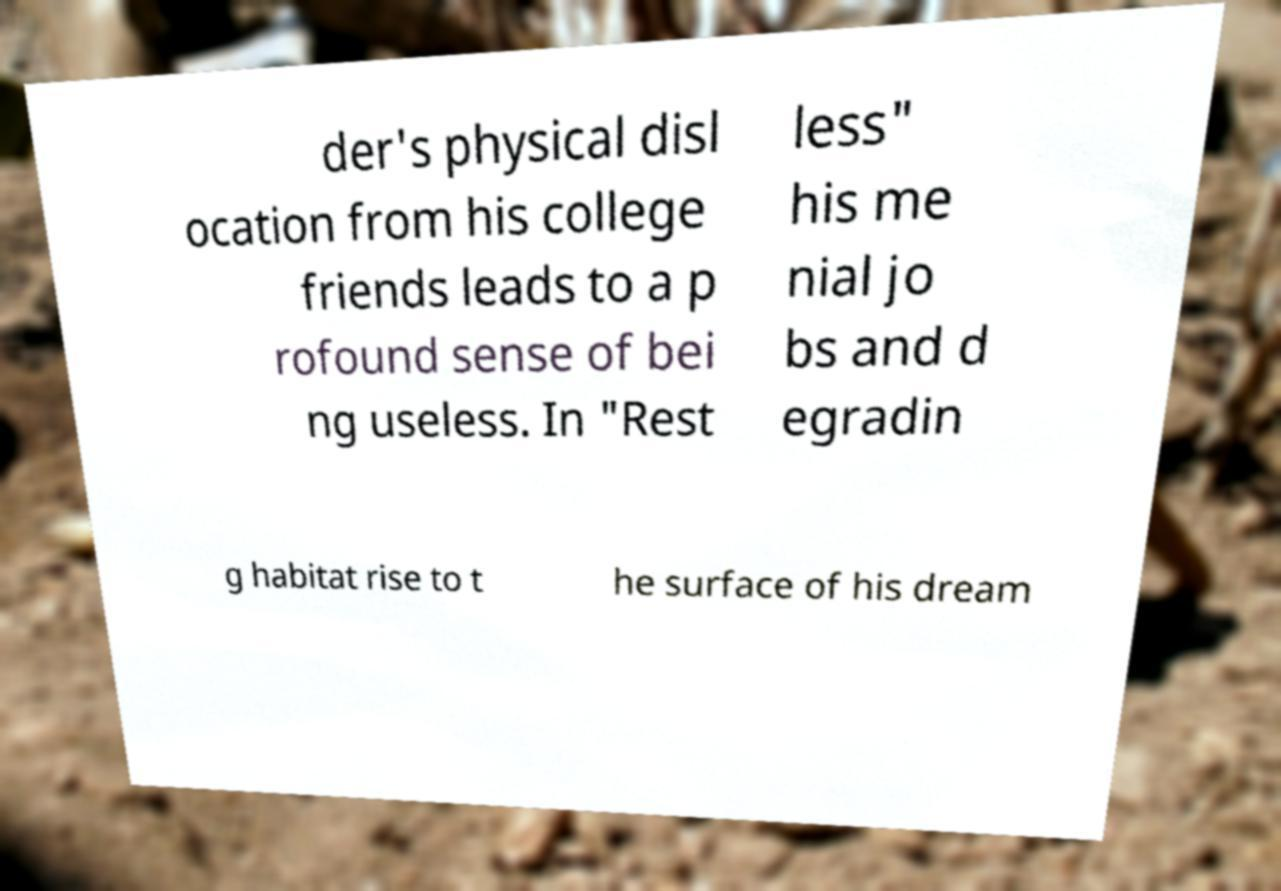Can you accurately transcribe the text from the provided image for me? der's physical disl ocation from his college friends leads to a p rofound sense of bei ng useless. In "Rest less" his me nial jo bs and d egradin g habitat rise to t he surface of his dream 